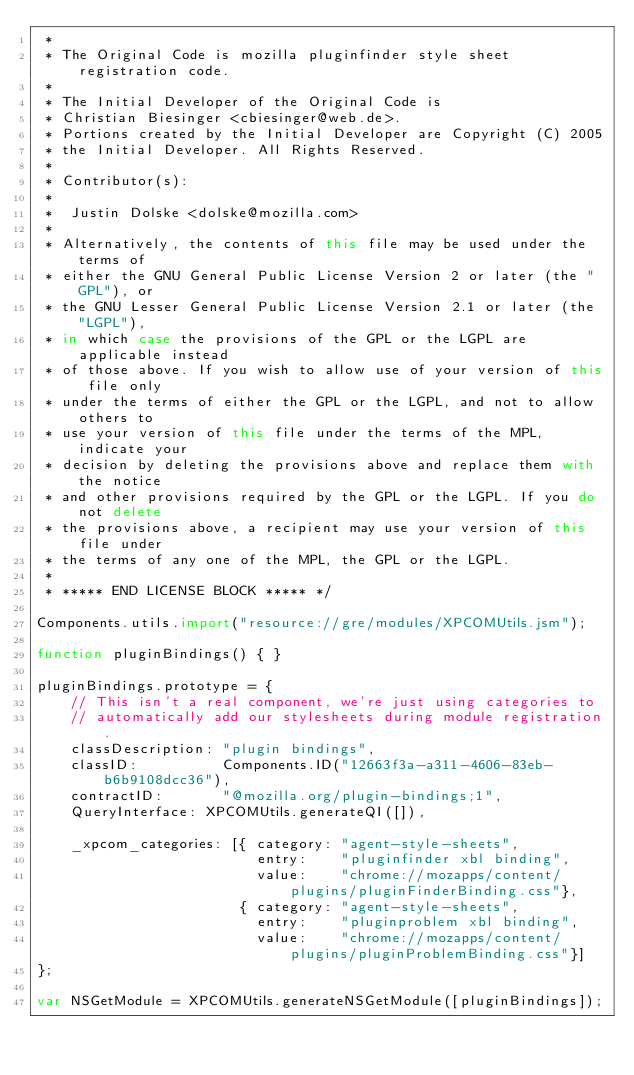<code> <loc_0><loc_0><loc_500><loc_500><_JavaScript_> *
 * The Original Code is mozilla pluginfinder style sheet registration code.
 *
 * The Initial Developer of the Original Code is
 * Christian Biesinger <cbiesinger@web.de>.
 * Portions created by the Initial Developer are Copyright (C) 2005
 * the Initial Developer. All Rights Reserved.
 *
 * Contributor(s):
 *
 *  Justin Dolske <dolske@mozilla.com>
 *
 * Alternatively, the contents of this file may be used under the terms of
 * either the GNU General Public License Version 2 or later (the "GPL"), or
 * the GNU Lesser General Public License Version 2.1 or later (the "LGPL"),
 * in which case the provisions of the GPL or the LGPL are applicable instead
 * of those above. If you wish to allow use of your version of this file only
 * under the terms of either the GPL or the LGPL, and not to allow others to
 * use your version of this file under the terms of the MPL, indicate your
 * decision by deleting the provisions above and replace them with the notice
 * and other provisions required by the GPL or the LGPL. If you do not delete
 * the provisions above, a recipient may use your version of this file under
 * the terms of any one of the MPL, the GPL or the LGPL.
 *
 * ***** END LICENSE BLOCK ***** */

Components.utils.import("resource://gre/modules/XPCOMUtils.jsm");

function pluginBindings() { }

pluginBindings.prototype = {
    // This isn't a real component, we're just using categories to
    // automatically add our stylesheets during module registration.
    classDescription: "plugin bindings",
    classID:          Components.ID("12663f3a-a311-4606-83eb-b6b9108dcc36"),
    contractID:       "@mozilla.org/plugin-bindings;1",
    QueryInterface: XPCOMUtils.generateQI([]),

    _xpcom_categories: [{ category: "agent-style-sheets",
                          entry:    "pluginfinder xbl binding",
                          value:    "chrome://mozapps/content/plugins/pluginFinderBinding.css"},
                        { category: "agent-style-sheets",
                          entry:    "pluginproblem xbl binding",
                          value:    "chrome://mozapps/content/plugins/pluginProblemBinding.css"}]
};

var NSGetModule = XPCOMUtils.generateNSGetModule([pluginBindings]);
</code> 